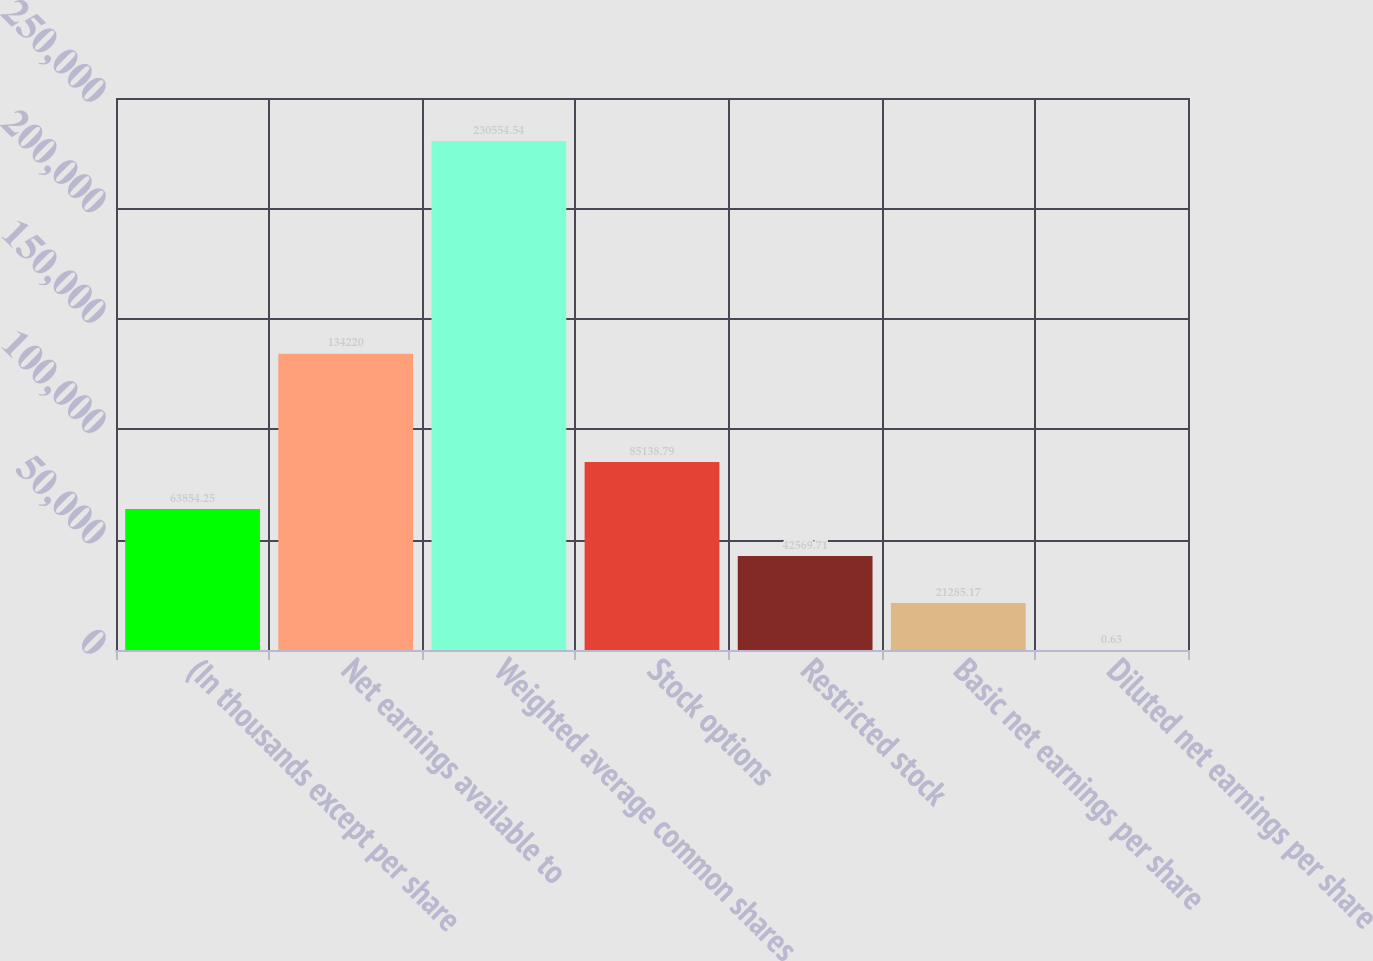<chart> <loc_0><loc_0><loc_500><loc_500><bar_chart><fcel>(In thousands except per share<fcel>Net earnings available to<fcel>Weighted average common shares<fcel>Stock options<fcel>Restricted stock<fcel>Basic net earnings per share<fcel>Diluted net earnings per share<nl><fcel>63854.2<fcel>134220<fcel>230555<fcel>85138.8<fcel>42569.7<fcel>21285.2<fcel>0.63<nl></chart> 